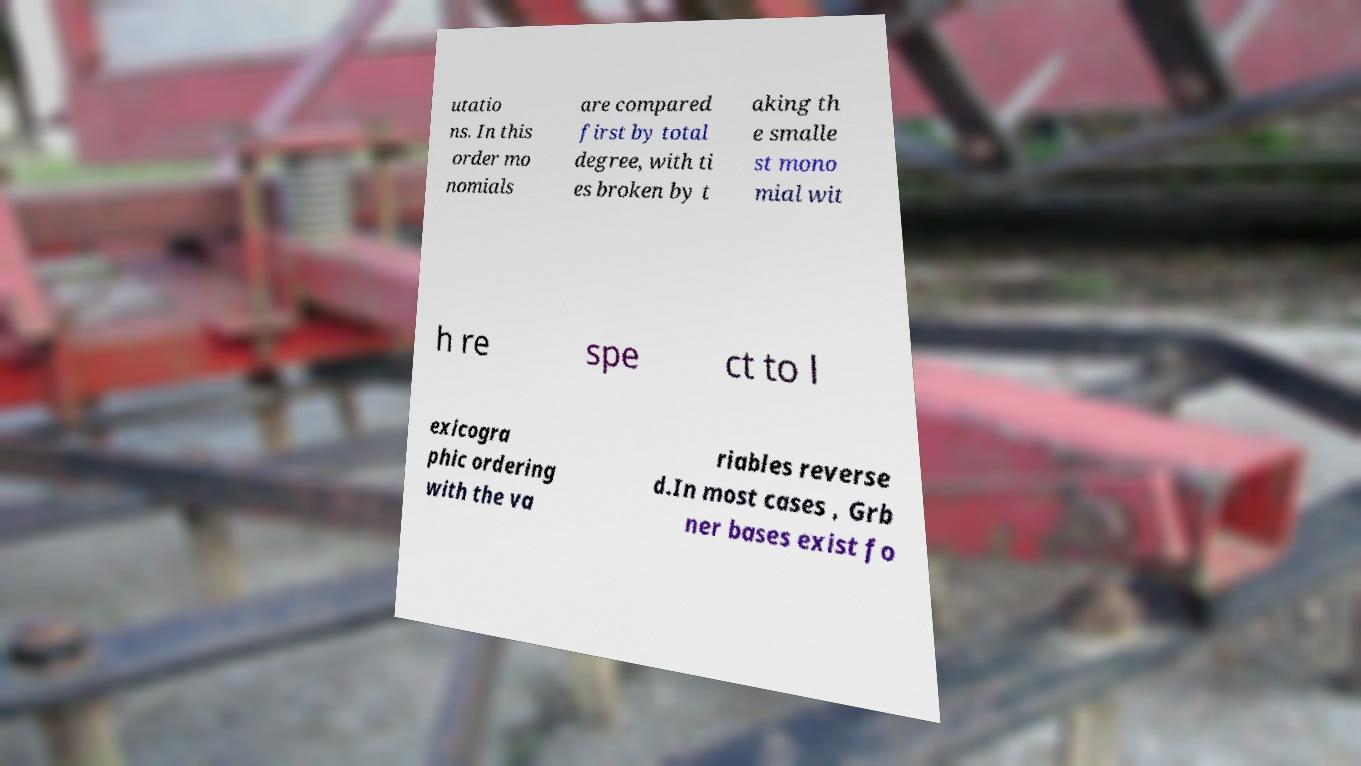Could you assist in decoding the text presented in this image and type it out clearly? utatio ns. In this order mo nomials are compared first by total degree, with ti es broken by t aking th e smalle st mono mial wit h re spe ct to l exicogra phic ordering with the va riables reverse d.In most cases , Grb ner bases exist fo 